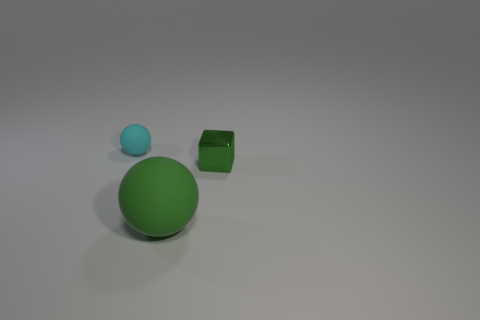Subtract all cyan balls. How many balls are left? 1 Add 3 big green matte spheres. How many objects exist? 6 Subtract all balls. How many objects are left? 1 Subtract 0 cyan cylinders. How many objects are left? 3 Subtract 1 cubes. How many cubes are left? 0 Subtract all green balls. Subtract all blue cubes. How many balls are left? 1 Subtract all small cyan rubber cubes. Subtract all tiny matte spheres. How many objects are left? 2 Add 2 cyan matte objects. How many cyan matte objects are left? 3 Add 1 big blue metal spheres. How many big blue metal spheres exist? 1 